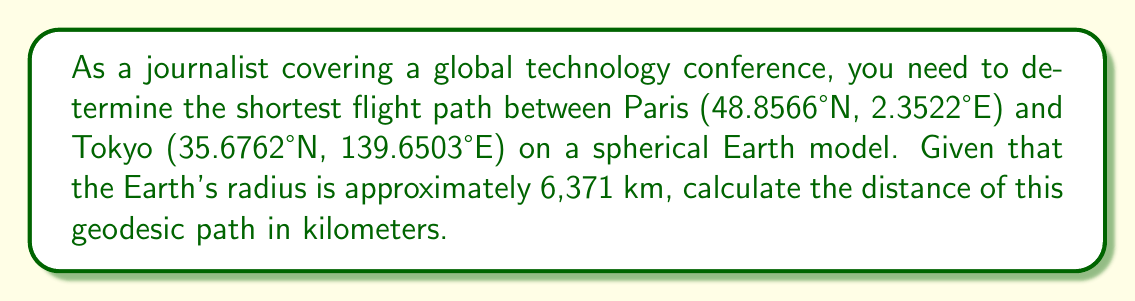Could you help me with this problem? To solve this problem, we'll use the spherical law of cosines formula for great circle distances. Let's follow these steps:

1. Convert the latitudes and longitudes from degrees to radians:
   Paris: $\phi_1 = 48.8566° \cdot \frac{\pi}{180} = 0.8527$ rad, $\lambda_1 = 2.3522° \cdot \frac{\pi}{180} = 0.0411$ rad
   Tokyo: $\phi_2 = 35.6762° \cdot \frac{\pi}{180} = 0.6228$ rad, $\lambda_2 = 139.6503° \cdot \frac{\pi}{180} = 2.4372$ rad

2. Calculate the central angle $\Delta\sigma$ using the spherical law of cosines:
   $$\Delta\sigma = \arccos(\sin\phi_1 \sin\phi_2 + \cos\phi_1 \cos\phi_2 \cos(\lambda_2 - \lambda_1))$$

3. Substitute the values:
   $$\Delta\sigma = \arccos(\sin(0.8527) \sin(0.6228) + \cos(0.8527) \cos(0.6228) \cos(2.4372 - 0.0411))$$

4. Calculate the result:
   $$\Delta\sigma = \arccos(0.0878) = 1.4825 \text{ rad}$$

5. The distance $d$ along the great circle is given by:
   $$d = R \cdot \Delta\sigma$$
   where $R$ is the Earth's radius (6,371 km).

6. Calculate the final distance:
   $$d = 6,371 \text{ km} \cdot 1.4825 = 9,445 \text{ km}$$

Thus, the geodesic path between Paris and Tokyo on a spherical Earth model is approximately 9,445 km.
Answer: 9,445 km 